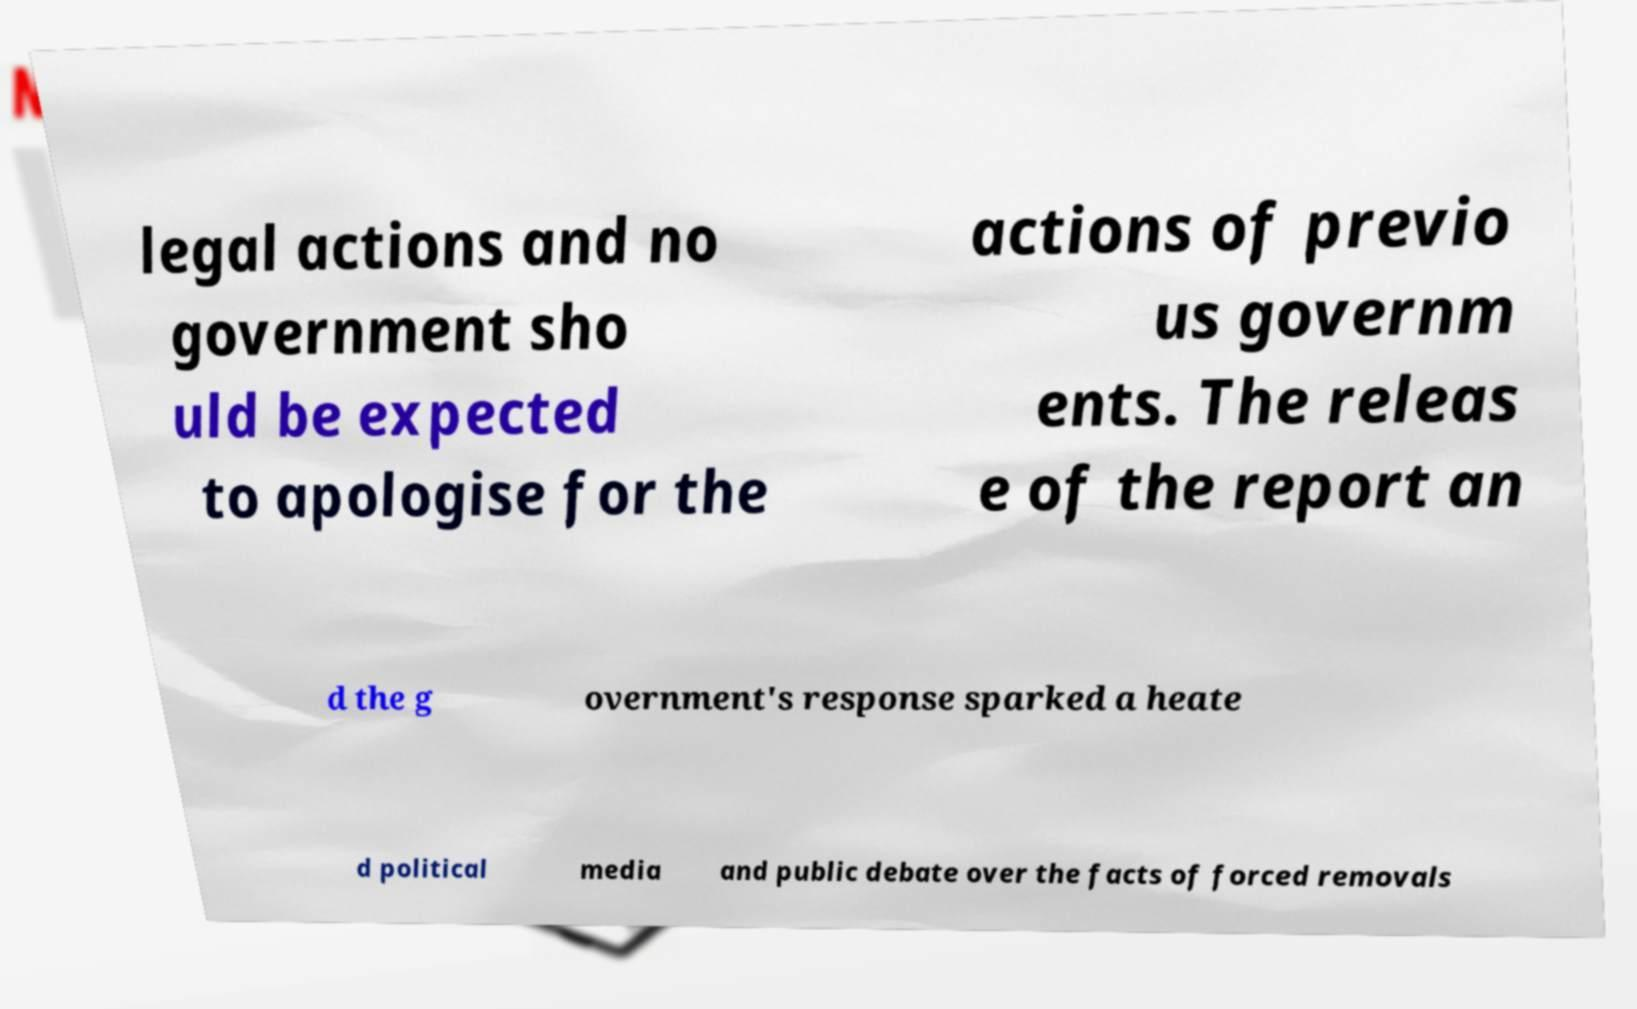Could you assist in decoding the text presented in this image and type it out clearly? legal actions and no government sho uld be expected to apologise for the actions of previo us governm ents. The releas e of the report an d the g overnment's response sparked a heate d political media and public debate over the facts of forced removals 